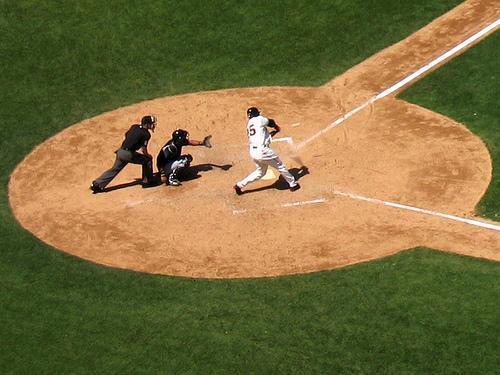How many men are visible?
Give a very brief answer. 3. How many horses are in the field?
Give a very brief answer. 0. 